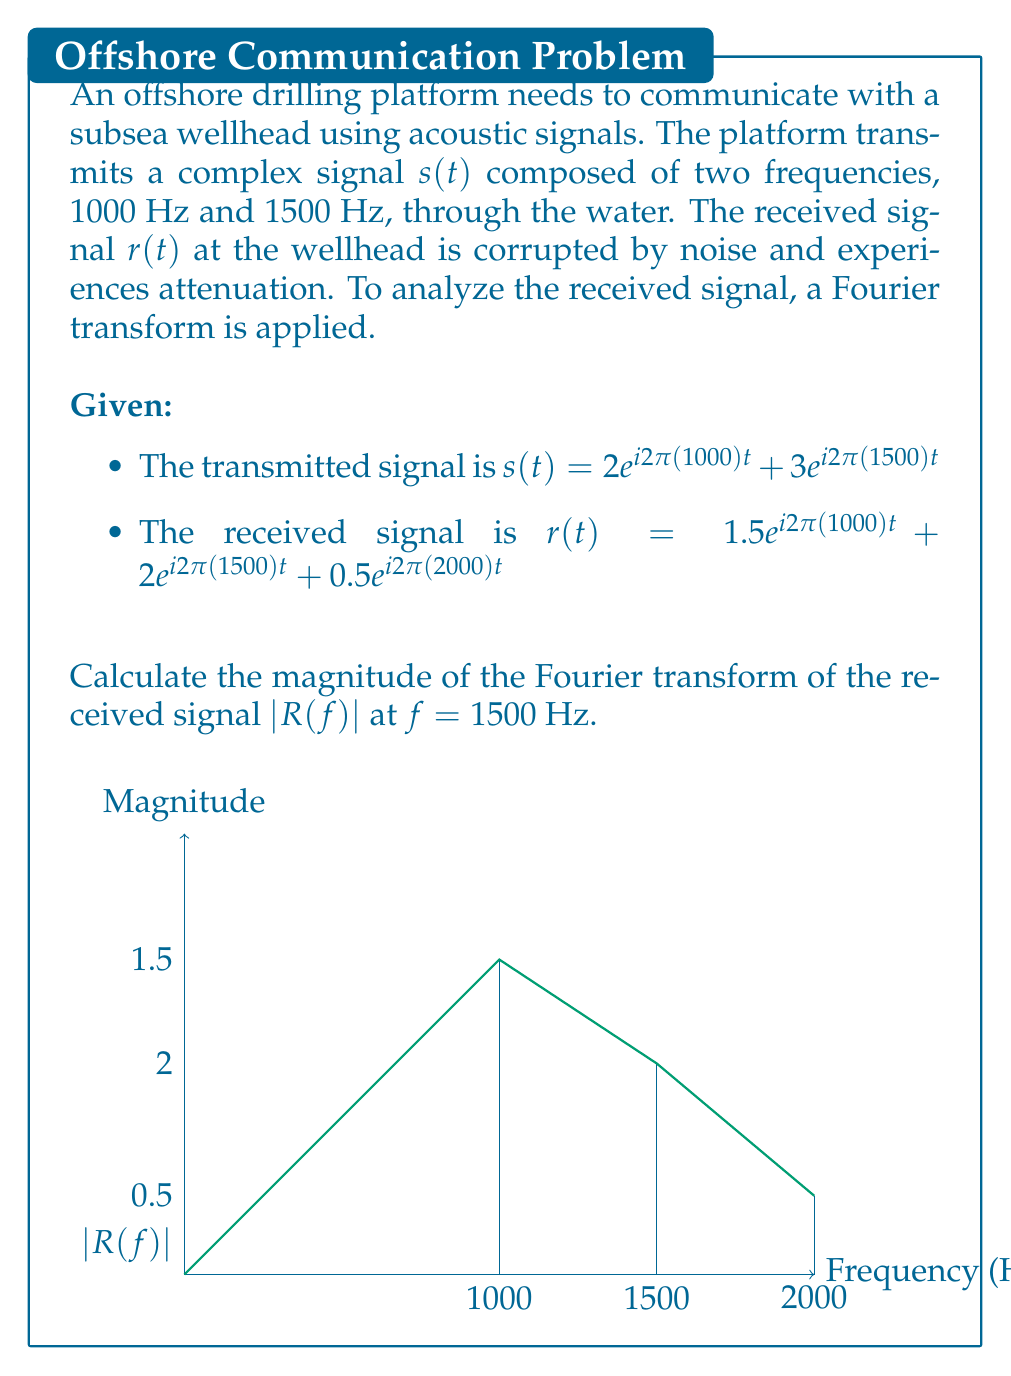Solve this math problem. To solve this problem, we'll follow these steps:

1) The Fourier transform of a complex exponential signal $e^{i2\pi f_0t}$ is a delta function $\delta(f-f_0)$.

2) The received signal $r(t)$ consists of three components:
   $r(t) = 1.5e^{i2\pi(1000)t} + 2e^{i2\pi(1500)t} + 0.5e^{i2\pi(2000)t}$

3) The Fourier transform of $r(t)$ is:
   $R(f) = 1.5\delta(f-1000) + 2\delta(f-1500) + 0.5\delta(f-2000)$

4) The magnitude of the Fourier transform $|R(f)|$ is:
   $|R(f)| = 1.5$ at $f = 1000$ Hz
   $|R(f)| = 2$ at $f = 1500$ Hz
   $|R(f)| = 0.5$ at $f = 2000$ Hz
   $|R(f)| = 0$ elsewhere

5) The question asks for $|R(f)|$ at $f = 1500$ Hz, which is 2.

This analysis shows that the original 1500 Hz component has been attenuated from 3 to 2 during transmission, and a new 2000 Hz component (possibly noise) has been introduced.
Answer: 2 